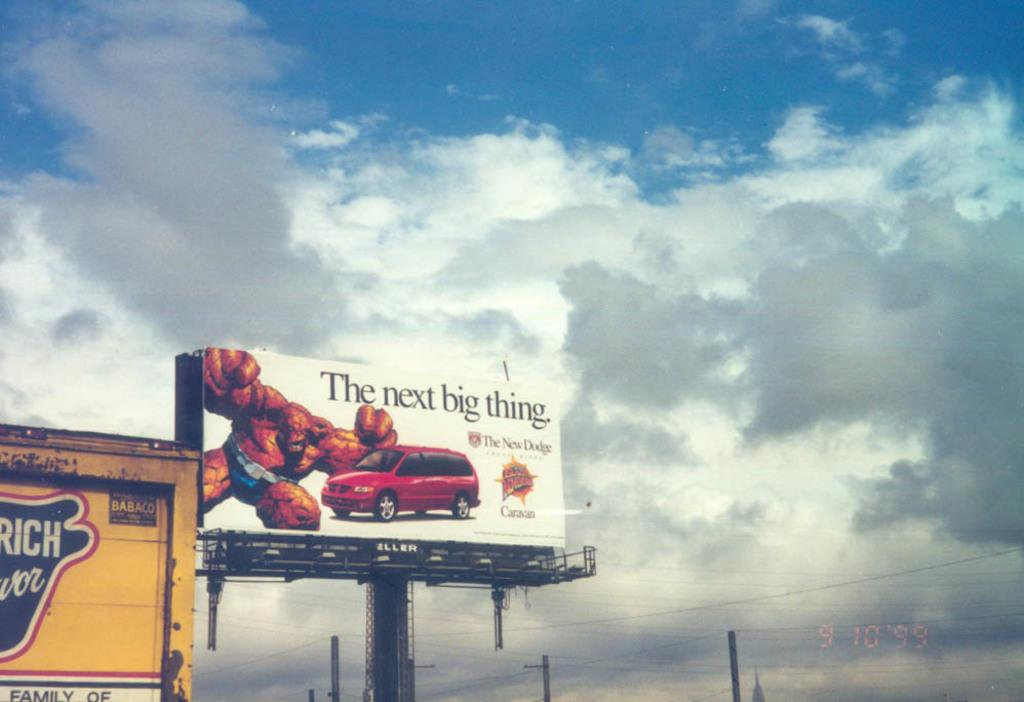<image>
Create a compact narrative representing the image presented. A billboard shows a Dodge caravan with a creating trying to crush it. 